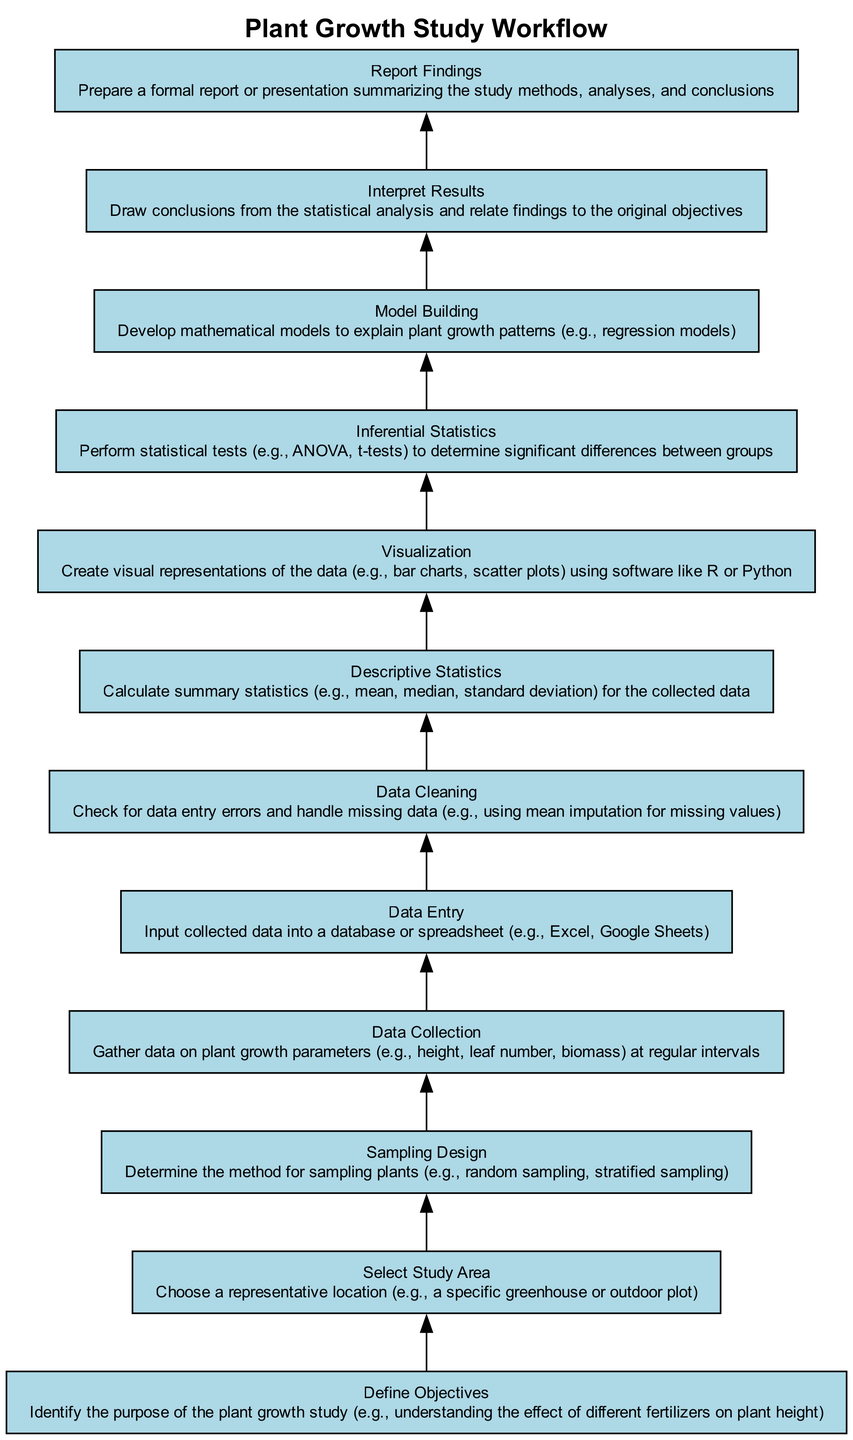What is the first step in the workflow? The first step in the workflow is "Define Objectives". It is located at the bottom of the diagram, indicating it is the starting point of the entire process.
Answer: Define Objectives How many total steps are in the workflow? By counting the nodes present in the diagram, there are eleven distinct steps in the workflow, starting from "Define Objectives" to "Report Findings".
Answer: Eleven What is the last step in the workflow? The last step, positioned at the top of the diagram, is "Report Findings". This indicates it concludes the entire data collection and analysis process.
Answer: Report Findings Which step follows "Data Cleaning"? After "Data Cleaning", the next step in the workflow is "Descriptive Statistics". This indicates a sequential process where cleaning data leads to statistical summarization.
Answer: Descriptive Statistics Which two steps are directly connected in a sequence before "Interpret Results"? The steps directly connected before "Interpret Results" are "Model Building" and "Inferential Statistics". This shows that the model building occurs only after inferential statistics have been performed.
Answer: Model Building and Inferential Statistics What type of statistical tests are performed in the "Inferential Statistics" step? The "Inferential Statistics" step includes performing statistical tests such as ANOVA and t-tests, indicating analysis related to group differences or effects.
Answer: ANOVA and t-tests Why is "Visualization" crucial in the workflow? "Visualization" is crucial because it allows researchers to create visual representations of the data, ensuring that the findings can be easily understood and communicated, which is vital for interpretation.
Answer: Create visual representations What is the relationship between "Data Collection" and "Data Entry"? The relationship is sequential; after "Data Collection," data is immediately entered into a database or spreadsheet. This step is crucial as it prepares the collected data for further processing.
Answer: Sequential relationship What does "Sampling Design" focus on within the workflow? "Sampling Design" focuses on determining the method for sampling plants, ensuring the integrity and representativity of the sample before data collection begins.
Answer: Method for sampling plants 